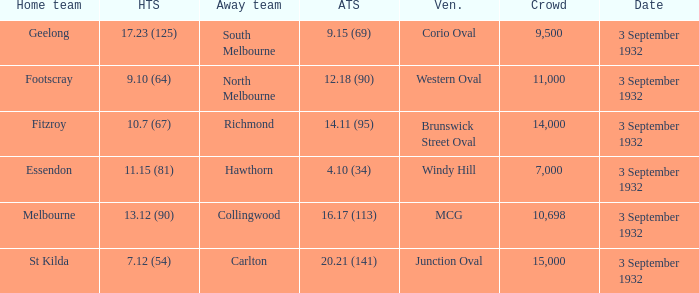What is the total Crowd number for the team that has an Away team score of 12.18 (90)? 11000.0. 